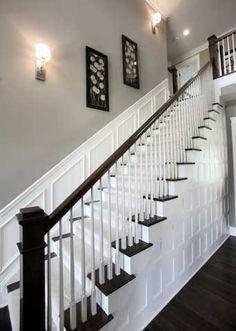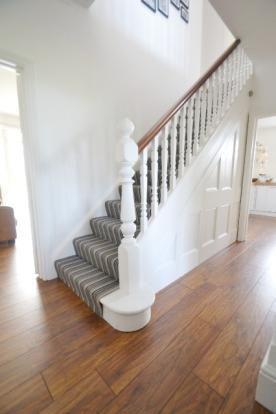The first image is the image on the left, the second image is the image on the right. For the images displayed, is the sentence "In at least on image there a two level empty staircase with a black handle and with rodes to protect someone from falling off." factually correct? Answer yes or no. No. The first image is the image on the left, the second image is the image on the right. For the images shown, is this caption "One image shows a cream-carpeted staircase that starts at the lower right, ascends, and turns back to the right, with a light fixture suspended over it." true? Answer yes or no. No. 